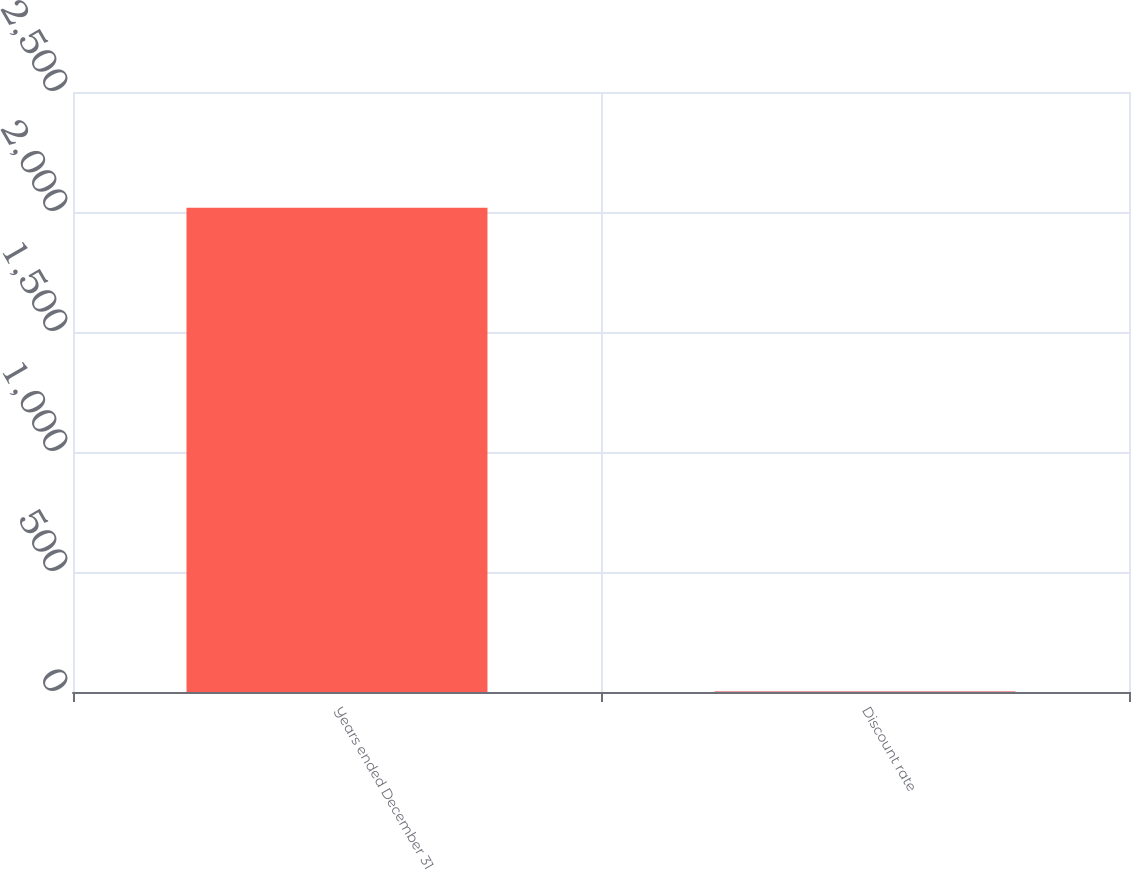Convert chart to OTSL. <chart><loc_0><loc_0><loc_500><loc_500><bar_chart><fcel>Years ended December 31<fcel>Discount rate<nl><fcel>2018<fcel>2.36<nl></chart> 